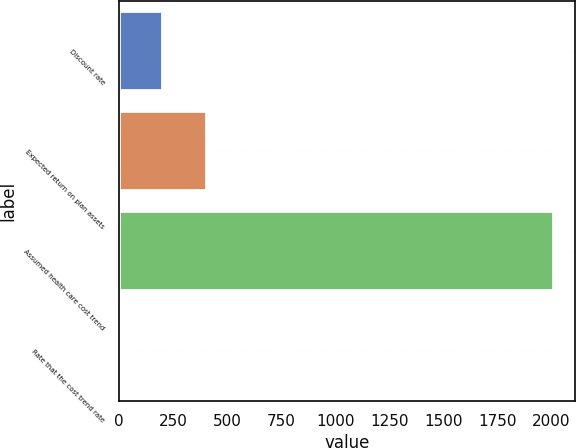Convert chart to OTSL. <chart><loc_0><loc_0><loc_500><loc_500><bar_chart><fcel>Discount rate<fcel>Expected return on plan assets<fcel>Assumed health care cost trend<fcel>Rate that the cost trend rate<nl><fcel>205.5<fcel>406<fcel>2010<fcel>5<nl></chart> 